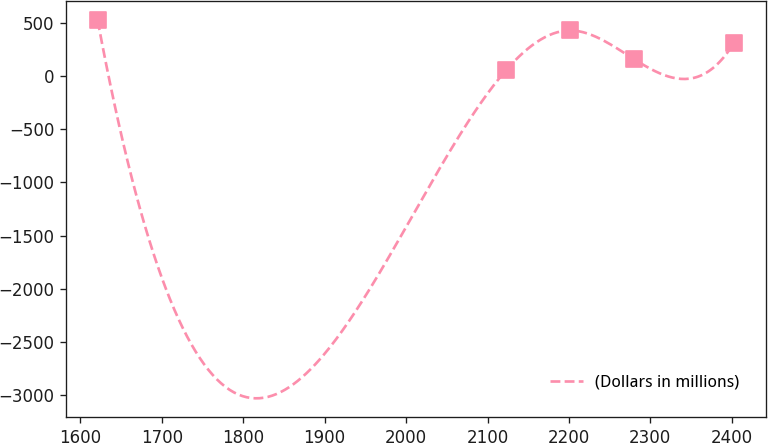Convert chart to OTSL. <chart><loc_0><loc_0><loc_500><loc_500><line_chart><ecel><fcel>(Dollars in millions)<nl><fcel>1621.21<fcel>526.52<nl><fcel>2123.28<fcel>61.52<nl><fcel>2201.44<fcel>431.4<nl><fcel>2279.6<fcel>163.05<nl><fcel>2402.79<fcel>315.48<nl></chart> 